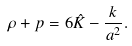<formula> <loc_0><loc_0><loc_500><loc_500>\rho + p = 6 \hat { K } - \frac { k } { a ^ { 2 } } .</formula> 